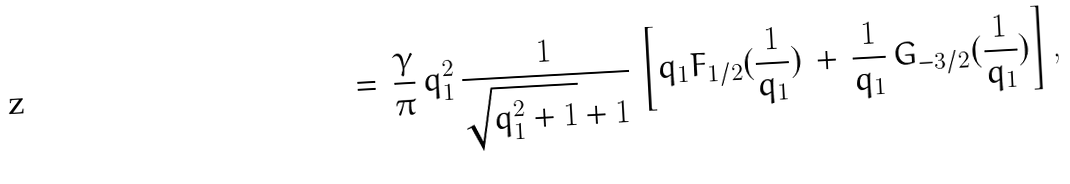Convert formula to latex. <formula><loc_0><loc_0><loc_500><loc_500>= \, \frac { \gamma } { \pi } \, q _ { 1 } ^ { 2 } \, \frac { 1 } { \sqrt { q _ { 1 } ^ { 2 } + 1 } + 1 } \, \left [ q _ { 1 } F _ { 1 / 2 } ( \frac { 1 } { q _ { 1 } } ) \, + \, \frac { 1 } { q _ { 1 } } \, G _ { - 3 / 2 } ( \frac { 1 } { q _ { 1 } } ) \right ] ,</formula> 